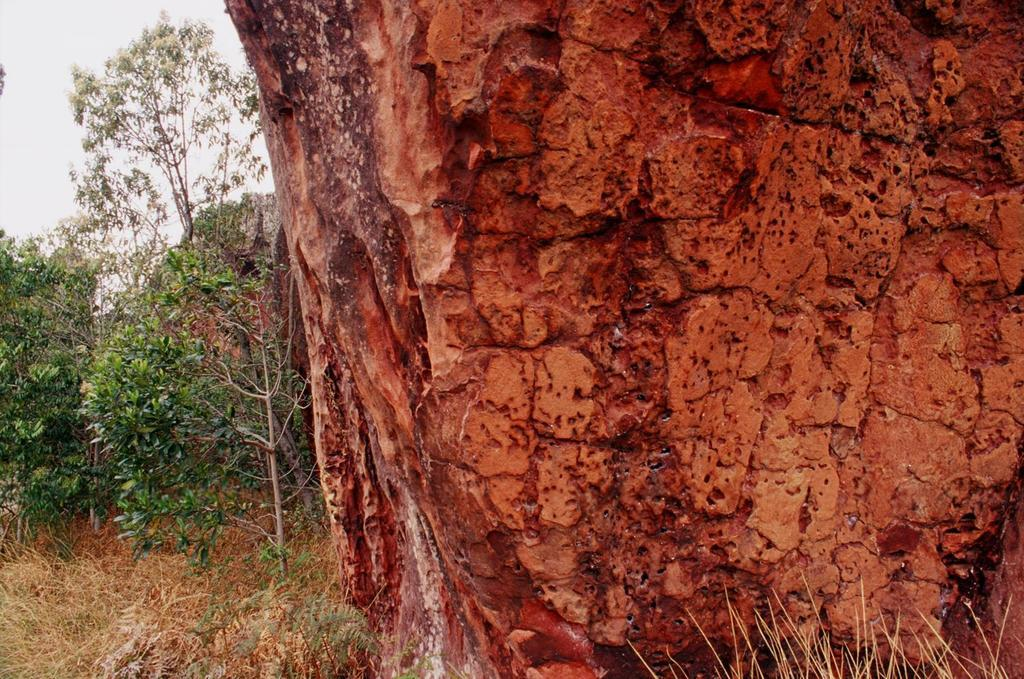What object is located on the right side of the image? There is a rock on the right side of the image. What type of vegetation can be seen in the background of the image? There are trees in the background of the image. What is the condition of the sky in the image? The sky is clear in the image. Can you tell me how many kitties are playing during the recess event in the image? There is no recess event or kitties present in the image; it features a rock and trees in the background. 